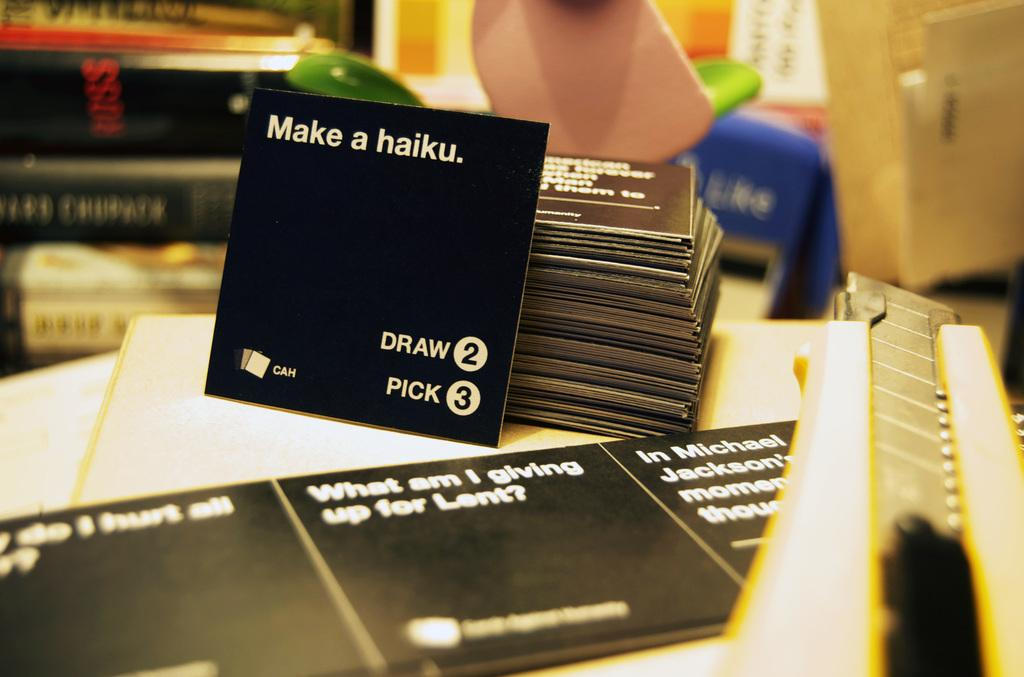<image>
Give a short and clear explanation of the subsequent image. A black card that instructs somebody to draw 2 and pick 3. 